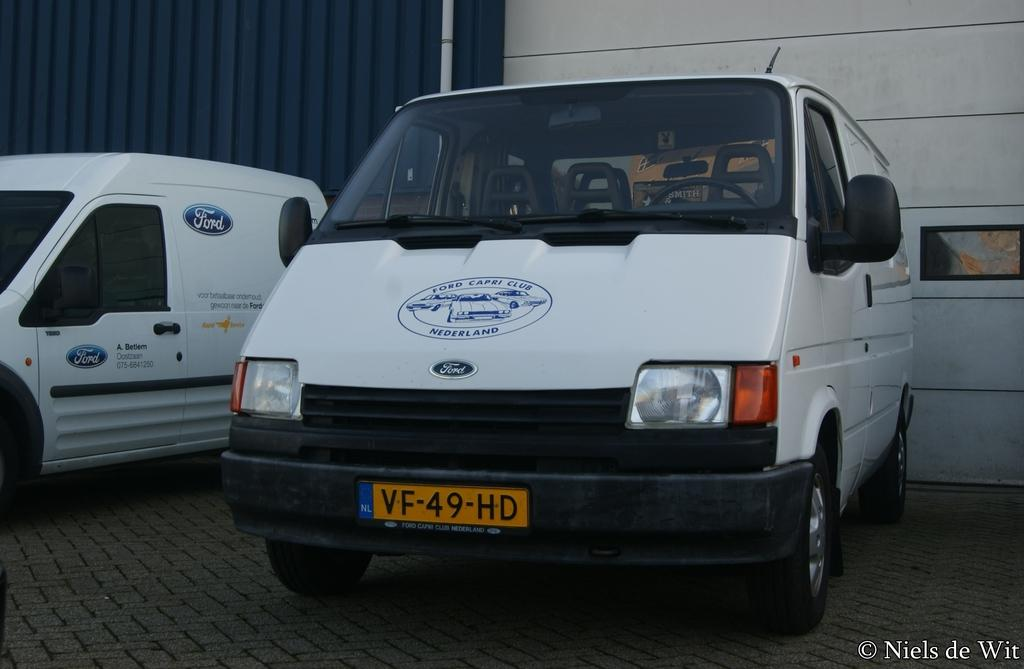<image>
Present a compact description of the photo's key features. White ford capri club nederland ford van parked by another ford van 